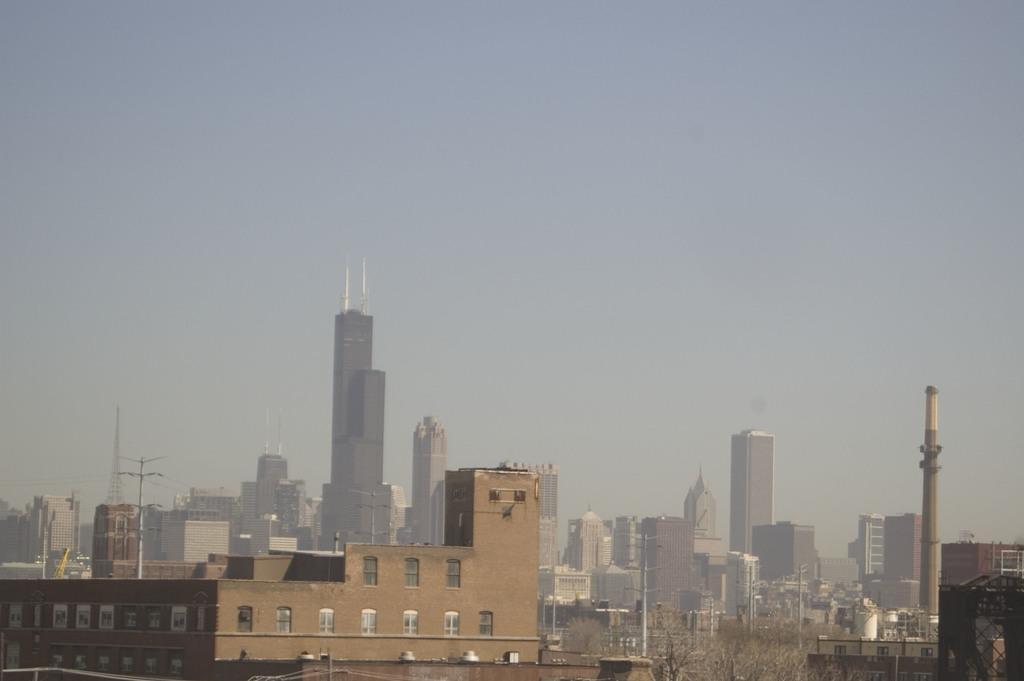Please provide a concise description of this image. In this picture I can see the buildings, skyscrapers, electric poles, concrete tower, signal tower, trees and iron tower. At the top I can see the sky. At the bottom I can see some poles and windows on the building. 